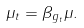Convert formula to latex. <formula><loc_0><loc_0><loc_500><loc_500>\mu _ { t } = \beta _ { g _ { t } } \mu .</formula> 